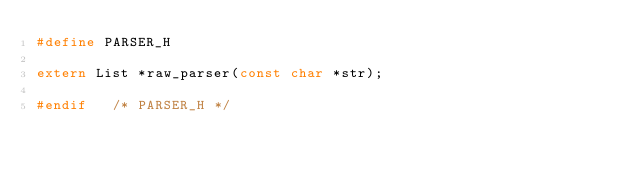Convert code to text. <code><loc_0><loc_0><loc_500><loc_500><_C_>#define PARSER_H

extern List *raw_parser(const char *str);

#endif   /* PARSER_H */
</code> 